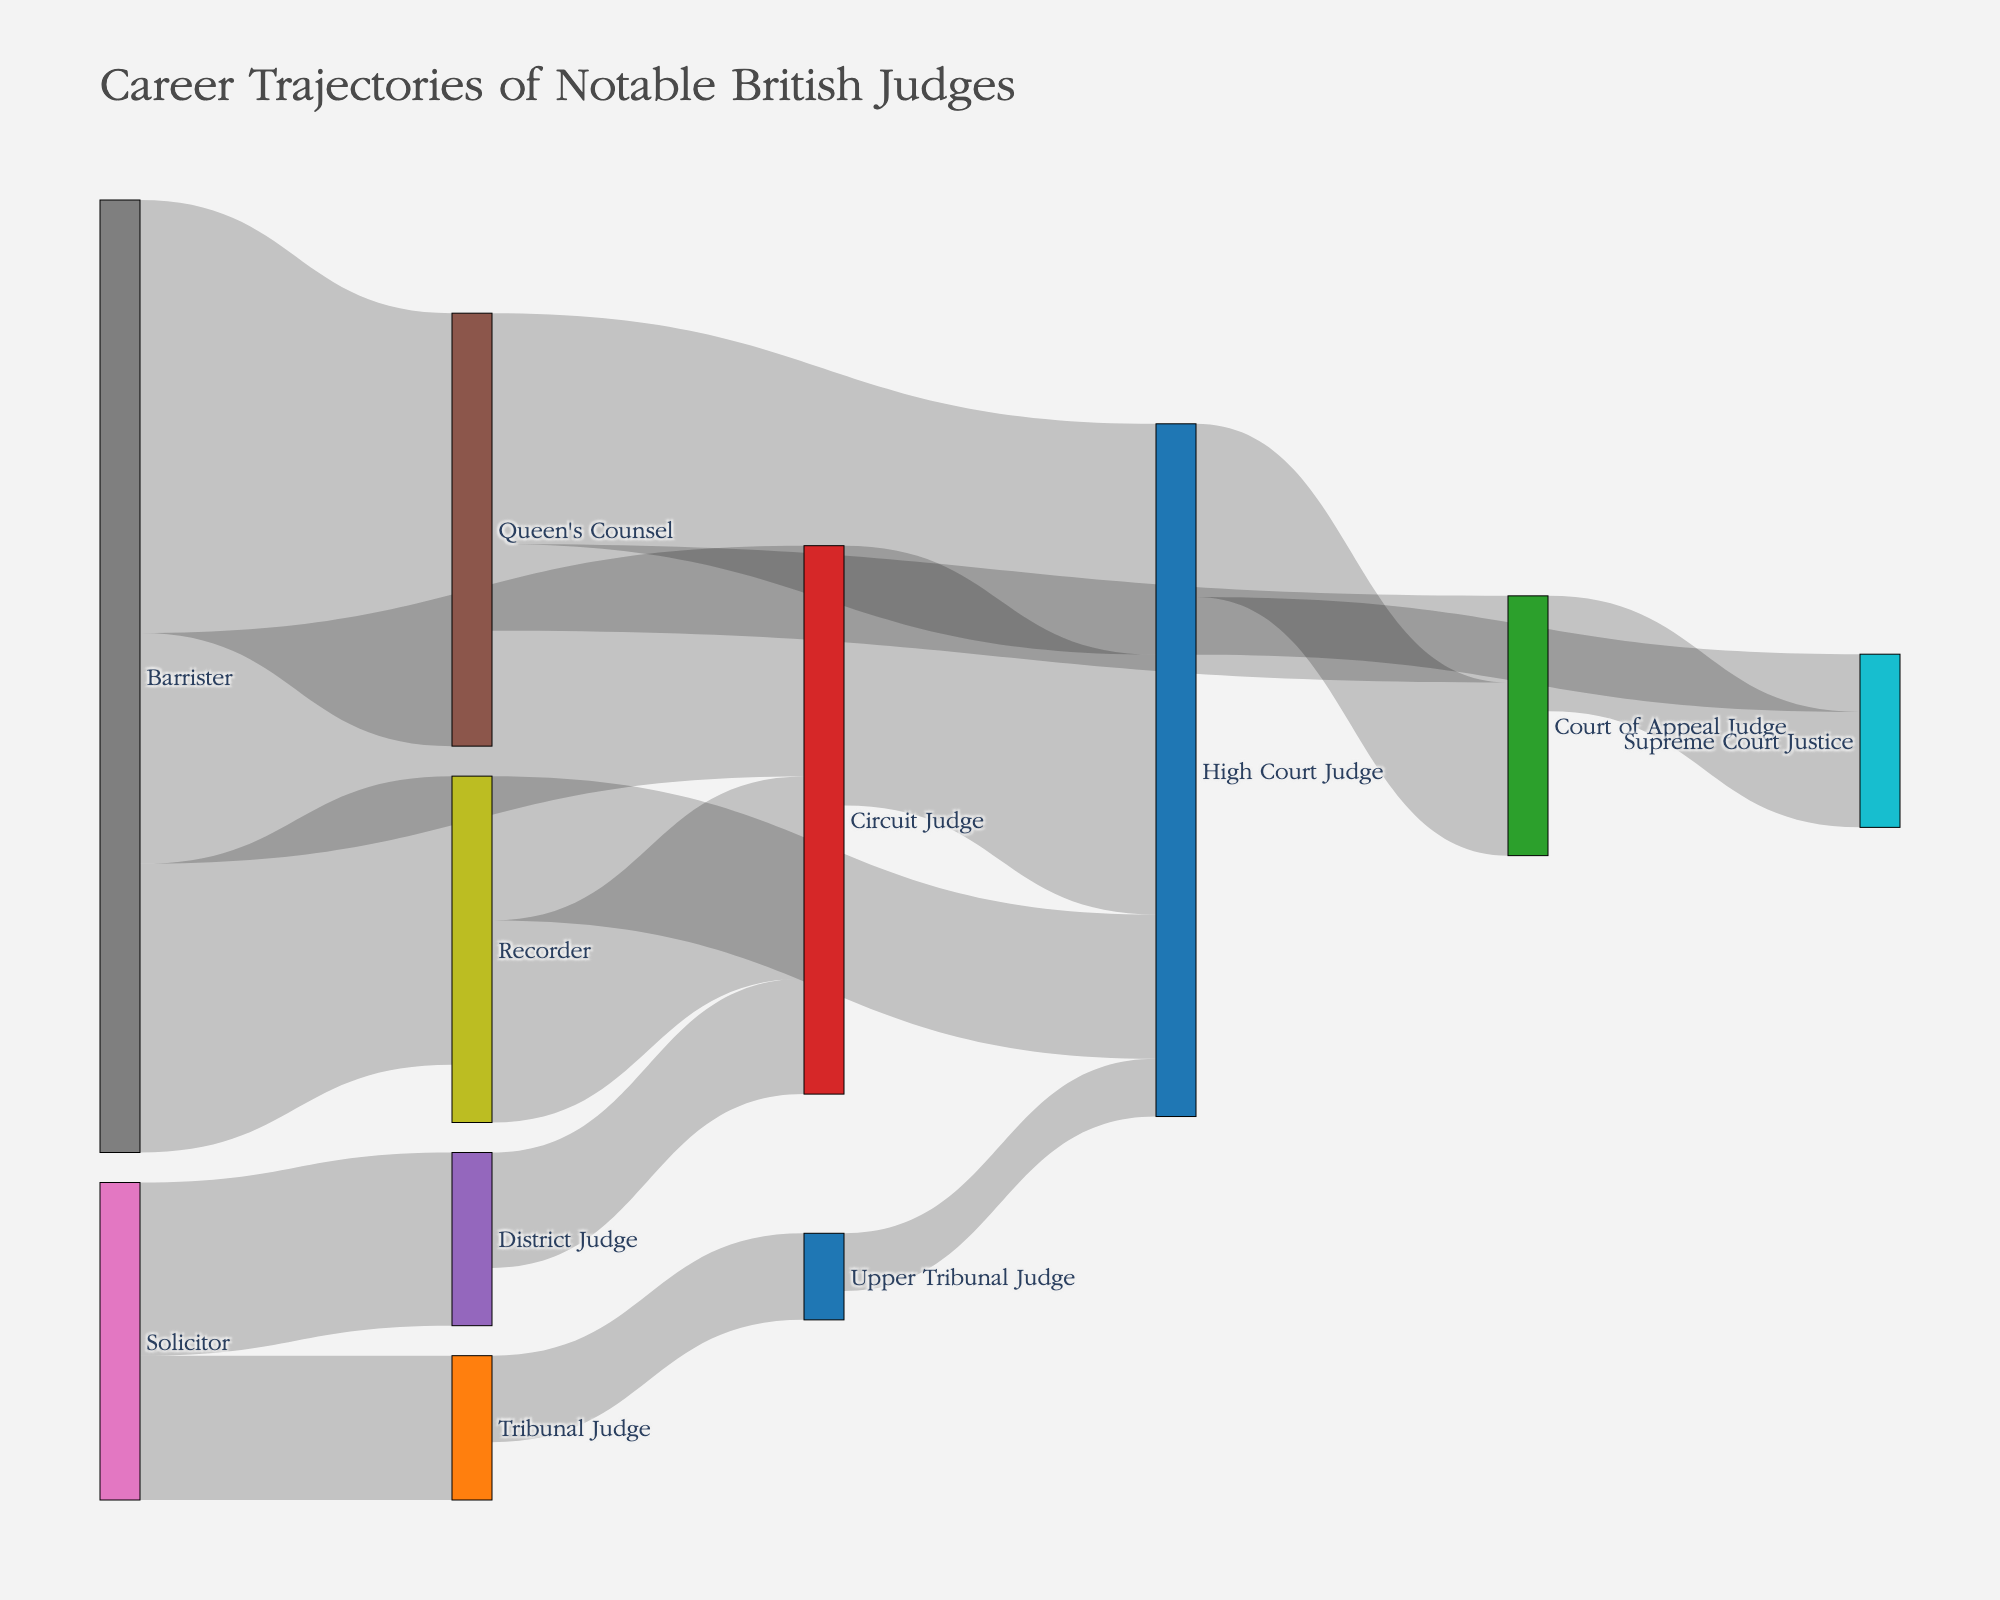Which legal role has the highest number of individuals starting their career as barristers? The bars connecting 'Barrister' to other roles indicate the flow of individuals. The thickest bar shows the highest value, which from the 'Barrister' node is 'Queen's Counsel' with a value of 15.
Answer: Queen's Counsel How many individuals progressed from Circuit Judge to High Court Judge? The Sankey diagram shows flows and their respective values between roles. The flow from 'Circuit Judge' to 'High Court Judge' has a value of 9.
Answer: 9 What is the sum of all individuals who advanced to Supreme Court Justice from any previous roles? Adding the values of flows that end at 'Supreme Court Justice': from 'High Court Judge' (2) and 'Court of Appeal Judge' (4). Thus, 2 + 4 = 6.
Answer: 6 Which role has more individuals coming directly from Recorder: Circuit Judge or High Court Judge? The flows from 'Recorder' to 'Circuit Judge' and 'Recorder' to 'High Court Judge' are compared. The values are 7 for 'Circuit Judge' and 5 for 'High Court Judge'.
Answer: Circuit Judge How does the number of individuals progressing from Solicitor to District Judge compare to those moving from Solicitor to Tribunal Judge? The values for flows from 'Solicitor' to 'District Judge' (6) and 'Solicitor' to 'Tribunal Judge' (5) are compared. 6 is greater than 5.
Answer: District Judge What is the total number of flows starting from Queen's Counsel? Summing up the values of flows originating from 'Queen's Counsel': to 'High Court Judge' (8) and 'Court of Appeal Judge' (3). Thus, 8 + 3 = 11.
Answer: 11 What is the career path with the most significant progression flow from Barrister to a final role? Following the path with the highest total flow from 'Barrister': 'Barrister' (Queen's Counsel: 15) -> 'Queen's Counsel' (High Court Judge: 8) -> 'High Court Judge' (Court of Appeal Judge: 6) -> 'Court of Appeal Judge' (Supreme Court Justice: 4). This sums to the largest flow, 15 + 8 + 6 + 4 = 33. This full path yields the most significant progression.
Answer: Barrister -> Queen's Counsel -> High Court Judge -> Court of Appeal Judge -> Supreme Court Justice Which role serves as a common transition for individuals moving from various initial roles? Observing the common endpoints of multiple flows from different sources: 'High Court Judge' appears as a target from 'Recorder', 'Circuit Judge', 'Queen's Counsel' and 'Upper Tribunal Judge'.
Answer: High Court Judge How many unique legal roles are depicted in the diagram? Counting all distinct nodes labeled in the figure indicates the different roles. In total, there are fourteen distinct roles represented.
Answer: 14 